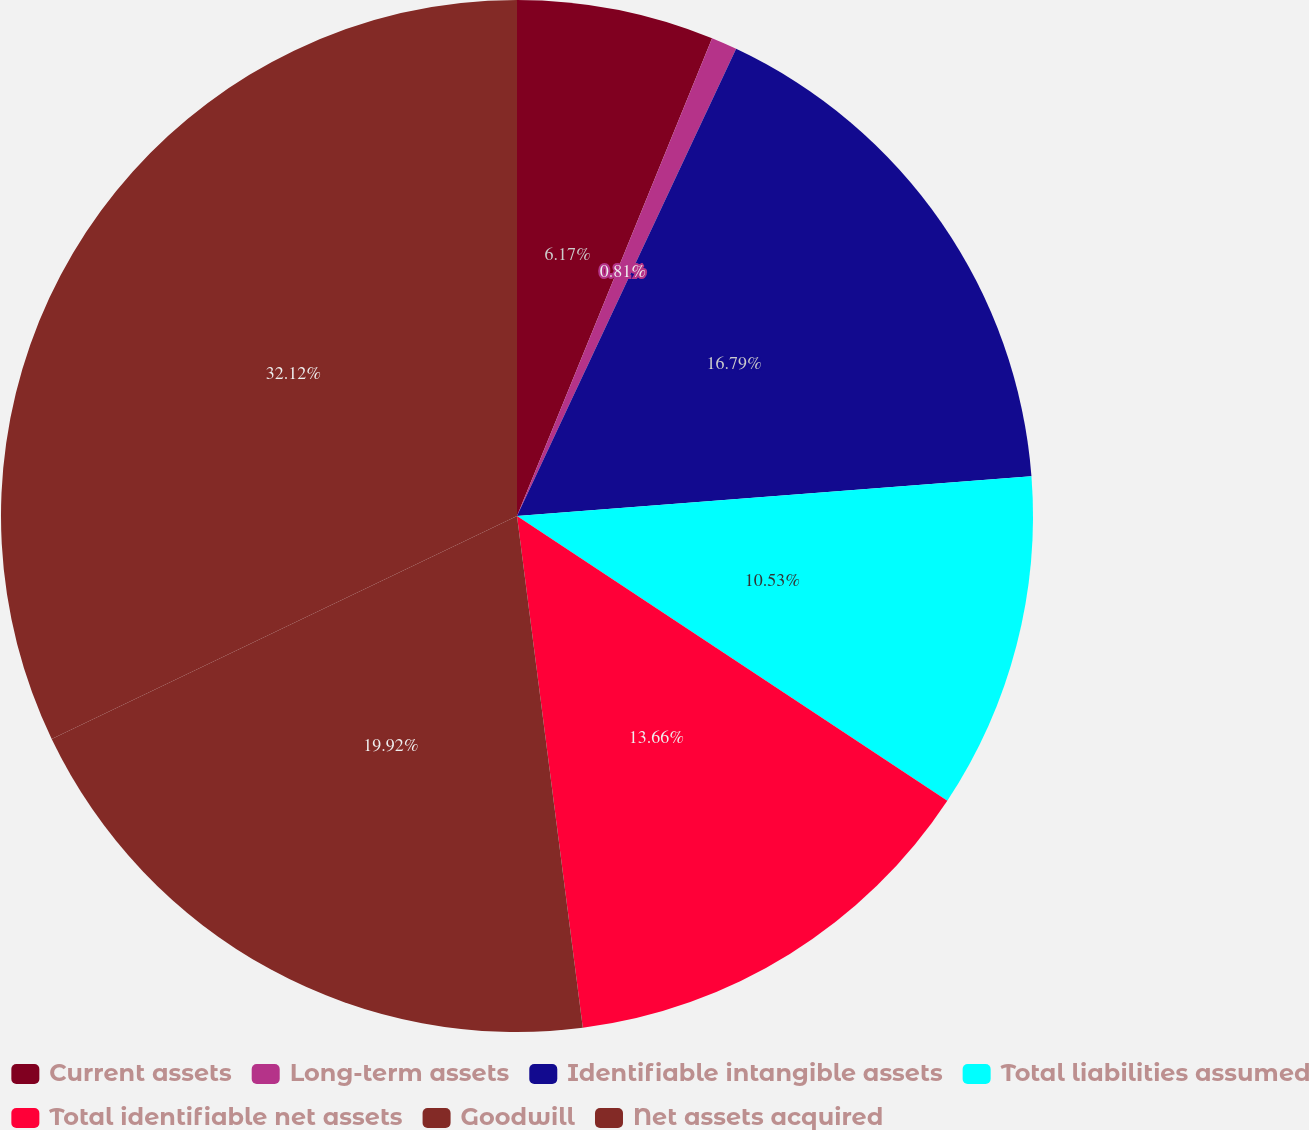Convert chart. <chart><loc_0><loc_0><loc_500><loc_500><pie_chart><fcel>Current assets<fcel>Long-term assets<fcel>Identifiable intangible assets<fcel>Total liabilities assumed<fcel>Total identifiable net assets<fcel>Goodwill<fcel>Net assets acquired<nl><fcel>6.17%<fcel>0.81%<fcel>16.79%<fcel>10.53%<fcel>13.66%<fcel>19.92%<fcel>32.11%<nl></chart> 